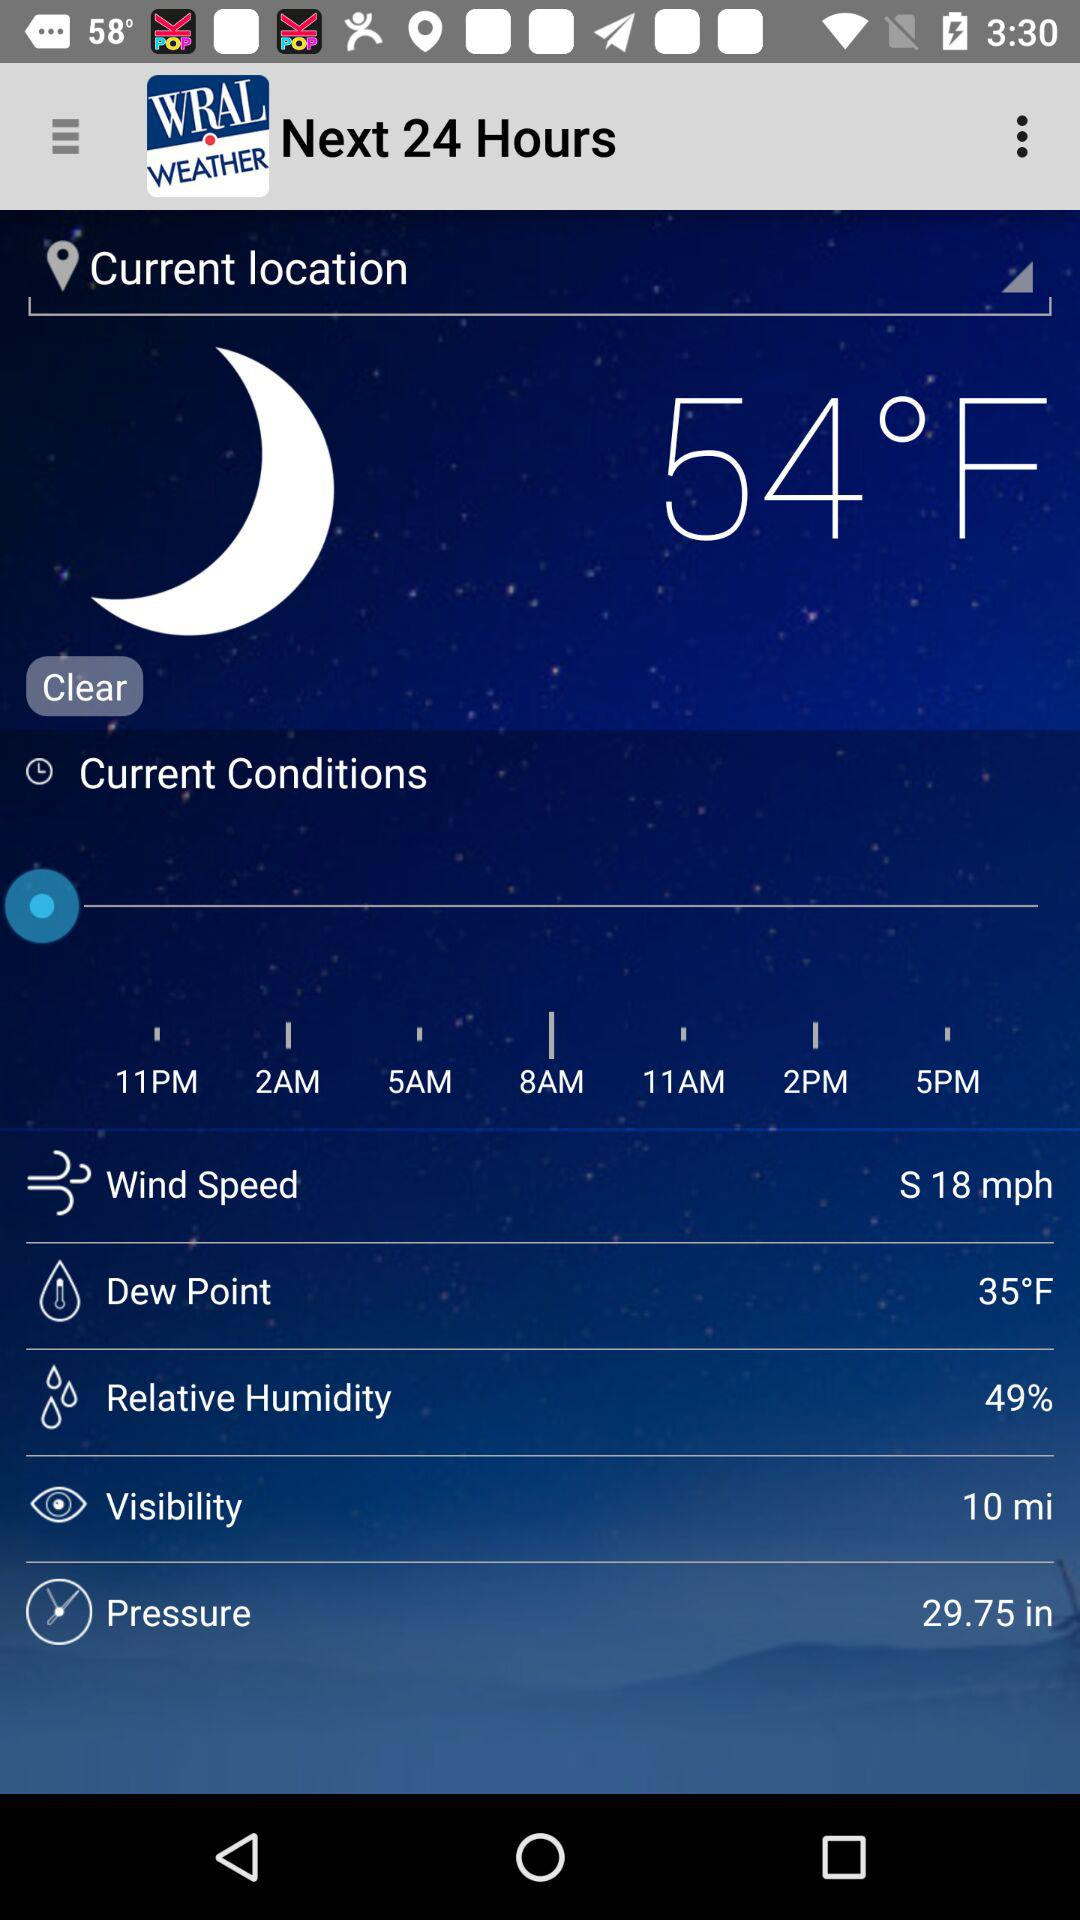What is the visibility distance? The visibility distance is 10 miles. 